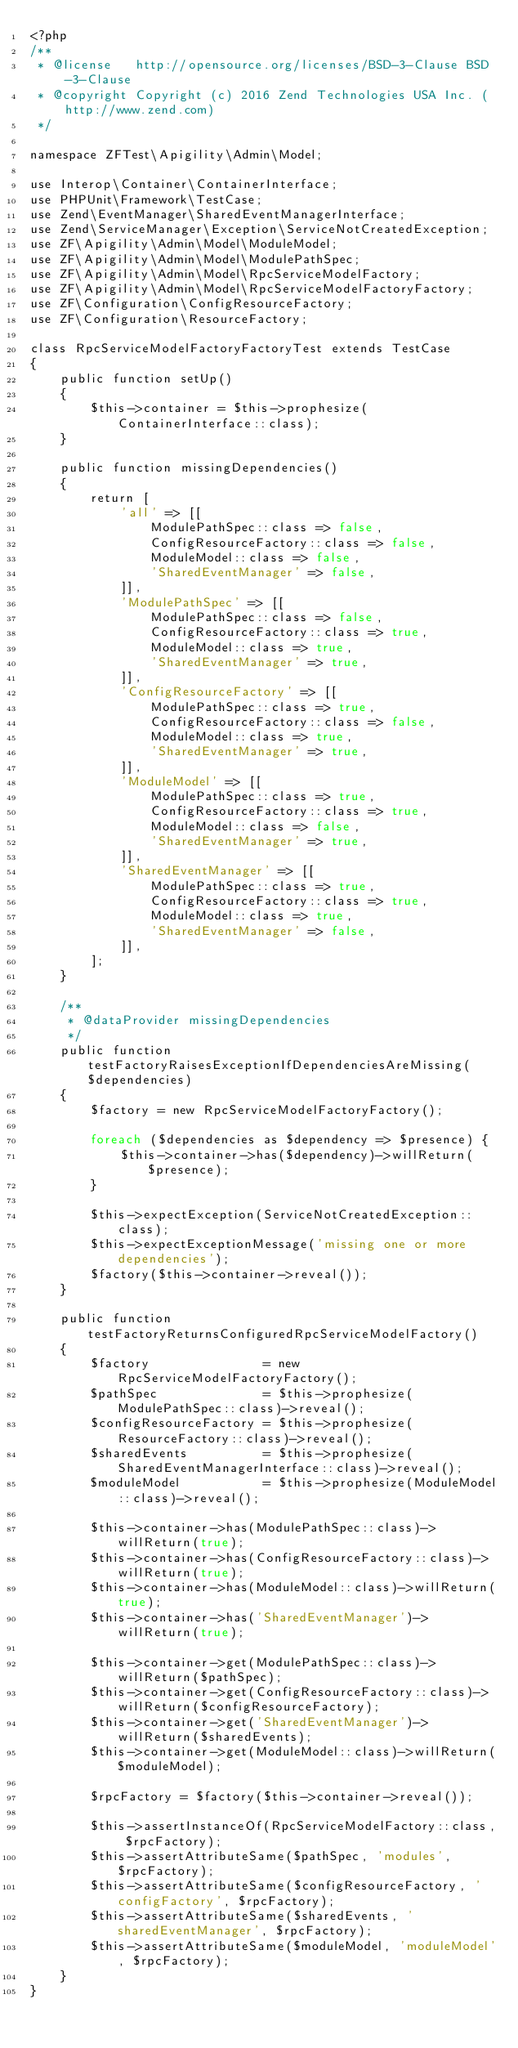<code> <loc_0><loc_0><loc_500><loc_500><_PHP_><?php
/**
 * @license   http://opensource.org/licenses/BSD-3-Clause BSD-3-Clause
 * @copyright Copyright (c) 2016 Zend Technologies USA Inc. (http://www.zend.com)
 */

namespace ZFTest\Apigility\Admin\Model;

use Interop\Container\ContainerInterface;
use PHPUnit\Framework\TestCase;
use Zend\EventManager\SharedEventManagerInterface;
use Zend\ServiceManager\Exception\ServiceNotCreatedException;
use ZF\Apigility\Admin\Model\ModuleModel;
use ZF\Apigility\Admin\Model\ModulePathSpec;
use ZF\Apigility\Admin\Model\RpcServiceModelFactory;
use ZF\Apigility\Admin\Model\RpcServiceModelFactoryFactory;
use ZF\Configuration\ConfigResourceFactory;
use ZF\Configuration\ResourceFactory;

class RpcServiceModelFactoryFactoryTest extends TestCase
{
    public function setUp()
    {
        $this->container = $this->prophesize(ContainerInterface::class);
    }

    public function missingDependencies()
    {
        return [
            'all' => [[
                ModulePathSpec::class => false,
                ConfigResourceFactory::class => false,
                ModuleModel::class => false,
                'SharedEventManager' => false,
            ]],
            'ModulePathSpec' => [[
                ModulePathSpec::class => false,
                ConfigResourceFactory::class => true,
                ModuleModel::class => true,
                'SharedEventManager' => true,
            ]],
            'ConfigResourceFactory' => [[
                ModulePathSpec::class => true,
                ConfigResourceFactory::class => false,
                ModuleModel::class => true,
                'SharedEventManager' => true,
            ]],
            'ModuleModel' => [[
                ModulePathSpec::class => true,
                ConfigResourceFactory::class => true,
                ModuleModel::class => false,
                'SharedEventManager' => true,
            ]],
            'SharedEventManager' => [[
                ModulePathSpec::class => true,
                ConfigResourceFactory::class => true,
                ModuleModel::class => true,
                'SharedEventManager' => false,
            ]],
        ];
    }

    /**
     * @dataProvider missingDependencies
     */
    public function testFactoryRaisesExceptionIfDependenciesAreMissing($dependencies)
    {
        $factory = new RpcServiceModelFactoryFactory();

        foreach ($dependencies as $dependency => $presence) {
            $this->container->has($dependency)->willReturn($presence);
        }

        $this->expectException(ServiceNotCreatedException::class);
        $this->expectExceptionMessage('missing one or more dependencies');
        $factory($this->container->reveal());
    }

    public function testFactoryReturnsConfiguredRpcServiceModelFactory()
    {
        $factory               = new RpcServiceModelFactoryFactory();
        $pathSpec              = $this->prophesize(ModulePathSpec::class)->reveal();
        $configResourceFactory = $this->prophesize(ResourceFactory::class)->reveal();
        $sharedEvents          = $this->prophesize(SharedEventManagerInterface::class)->reveal();
        $moduleModel           = $this->prophesize(ModuleModel::class)->reveal();

        $this->container->has(ModulePathSpec::class)->willReturn(true);
        $this->container->has(ConfigResourceFactory::class)->willReturn(true);
        $this->container->has(ModuleModel::class)->willReturn(true);
        $this->container->has('SharedEventManager')->willReturn(true);

        $this->container->get(ModulePathSpec::class)->willReturn($pathSpec);
        $this->container->get(ConfigResourceFactory::class)->willReturn($configResourceFactory);
        $this->container->get('SharedEventManager')->willReturn($sharedEvents);
        $this->container->get(ModuleModel::class)->willReturn($moduleModel);

        $rpcFactory = $factory($this->container->reveal());

        $this->assertInstanceOf(RpcServiceModelFactory::class, $rpcFactory);
        $this->assertAttributeSame($pathSpec, 'modules', $rpcFactory);
        $this->assertAttributeSame($configResourceFactory, 'configFactory', $rpcFactory);
        $this->assertAttributeSame($sharedEvents, 'sharedEventManager', $rpcFactory);
        $this->assertAttributeSame($moduleModel, 'moduleModel', $rpcFactory);
    }
}
</code> 